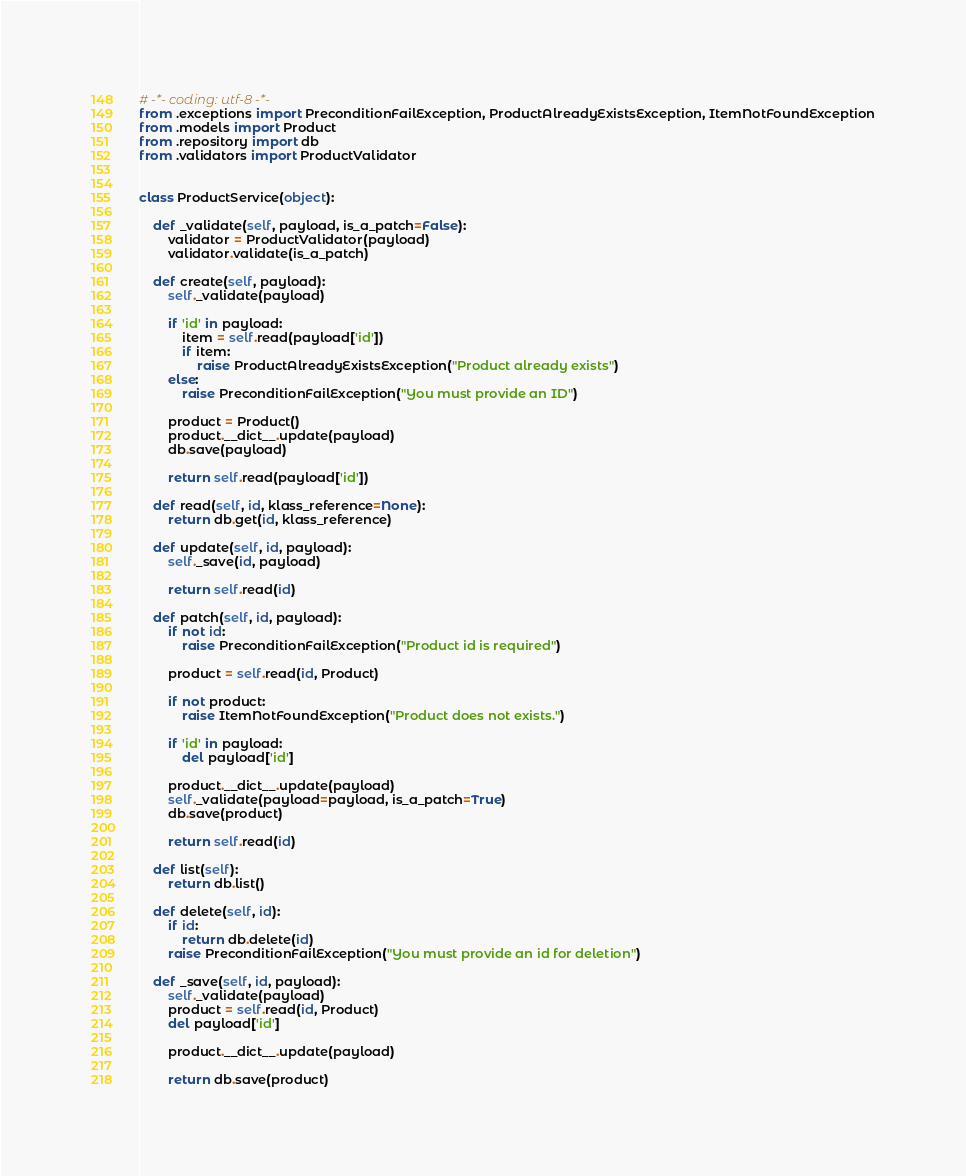<code> <loc_0><loc_0><loc_500><loc_500><_Python_># -*- coding: utf-8 -*-
from .exceptions import PreconditionFailException, ProductAlreadyExistsException, ItemNotFoundException
from .models import Product
from .repository import db
from .validators import ProductValidator


class ProductService(object):

    def _validate(self, payload, is_a_patch=False):
        validator = ProductValidator(payload)
        validator.validate(is_a_patch)

    def create(self, payload):
        self._validate(payload)

        if 'id' in payload:
            item = self.read(payload['id'])
            if item:
                raise ProductAlreadyExistsException("Product already exists")
        else:
            raise PreconditionFailException("You must provide an ID")

        product = Product()
        product.__dict__.update(payload)
        db.save(payload)

        return self.read(payload['id'])

    def read(self, id, klass_reference=None):
        return db.get(id, klass_reference)

    def update(self, id, payload):
        self._save(id, payload)

        return self.read(id)

    def patch(self, id, payload):
        if not id:
            raise PreconditionFailException("Product id is required")

        product = self.read(id, Product)

        if not product:
            raise ItemNotFoundException("Product does not exists.")

        if 'id' in payload:
            del payload['id']

        product.__dict__.update(payload)
        self._validate(payload=payload, is_a_patch=True)
        db.save(product)

        return self.read(id)

    def list(self):
        return db.list()

    def delete(self, id):
        if id:
            return db.delete(id)
        raise PreconditionFailException("You must provide an id for deletion")

    def _save(self, id, payload):
        self._validate(payload)
        product = self.read(id, Product)
        del payload['id']

        product.__dict__.update(payload)

        return db.save(product)
</code> 